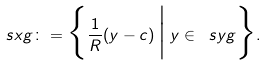<formula> <loc_0><loc_0><loc_500><loc_500>\ s x g \colon = \Big \{ \frac { 1 } { R } ( y - c ) \, \Big | \Big . \, y \in \ s y g \Big \} .</formula> 